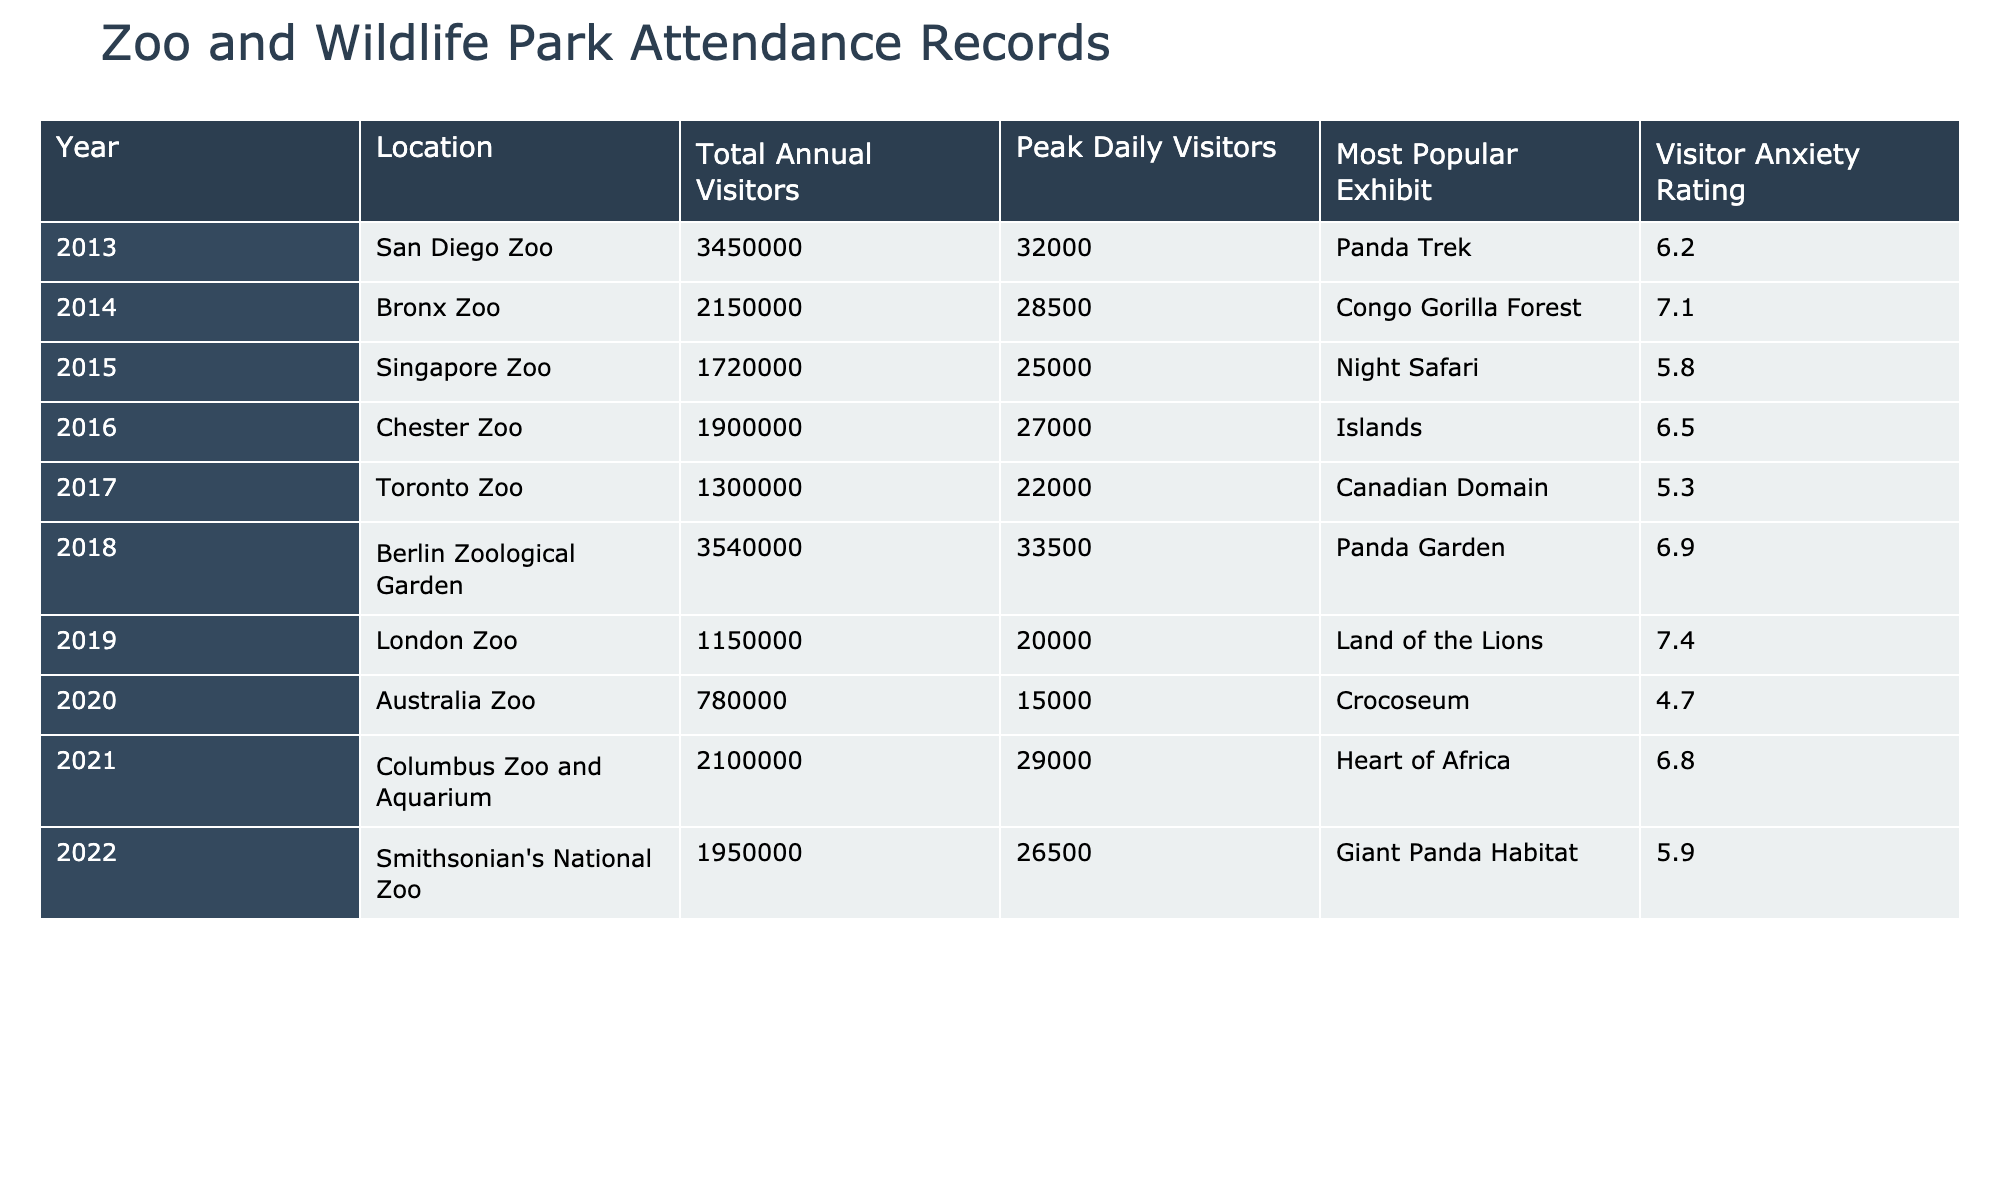What was the highest total annual visitors recorded in the given years? By scanning the Total Annual Visitors column, the highest number is 3,540,000 from the Berlin Zoological Garden in 2018.
Answer: 3,540,000 Which zoo had the lowest peak daily visitors? Looking at the Peak Daily Visitors column, the Australia Zoo had the lowest peak with 15,000 visitors in 2020.
Answer: 15,000 What was the average visitor anxiety rating for all zoos in 2019? In 2019, there was only one zoo listed, the London Zoo, with a visitor anxiety rating of 7.4. Therefore, the average is simply 7.4.
Answer: 7.4 Which zoo had the most popular exhibit named "Heart of Africa"? This exhibit is associated with the Columbus Zoo and Aquarium as noted in the Most Popular Exhibit column for the year 2021.
Answer: Columbus Zoo and Aquarium What was the total annual visitors for zoos in 2020 and how does it compare to 2018? In 2020, the Australia Zoo had 780,000 visitors. In 2018, the Berlin Zoological Garden had 3,540,000 visitors. The difference is 3,540,000 - 780,000 = 2,760,000, meaning 2018 was significantly higher.
Answer: 2,760,000 Was the visitor anxiety rating in 2016 higher or lower than in 2014? The visitor anxiety rating for Chester Zoo in 2016 was 6.5, while for Bronx Zoo in 2014, it was 7.1. Since 6.5 < 7.1, it is lower.
Answer: Lower What is the sum of total annual visitors across all years listed? Adding up all total annual visitors: 3,450,000 (2013) + 2,150,000 (2014) + 1,720,000 (2015) + 1,900,000 (2016) + 1,300,000 (2017) + 3,540,000 (2018) + 1,150,000 (2019) + 780,000 (2020) + 2,100,000 (2021) + 1,950,000 (2022) = 21,570,000.
Answer: 21,570,000 Which year had the highest visitor anxiety rating and how much is that rating? Scanning the Visitor Anxiety Rating column, the highest rating is 7.4 corresponding to the London Zoo in 2019.
Answer: 7.4 Is it true that all zoos listed had a visitor anxiety rating above 5? No, the Australia Zoo in 2020 had a visitor anxiety rating of 4.7, which is below 5.
Answer: False How many years had more than 2 million total annual visitors? Checking the Total Annual Visitors column, the years with over 2 million are 2013, 2014, 2018, and 2021, which totals 4 years.
Answer: 4 